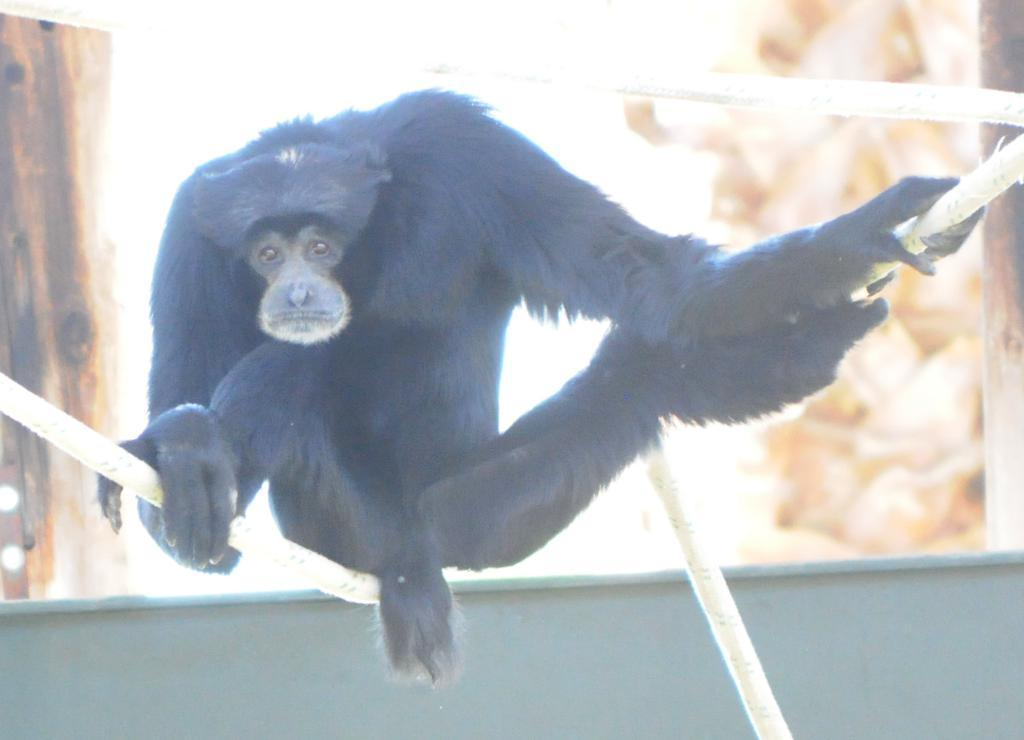What is the main subject of the image? There is an animal sitting on a rope in the image. What can be seen in the background of the image? There is a wall and wooden objects in the background of the image. How would you describe the background of the image? The background of the image is blurry. What type of toothbrush is the animal using in the image? There is no toothbrush present in the image. How many additional animals can be seen in the image? The provided facts do not mention any other animals in the image. 